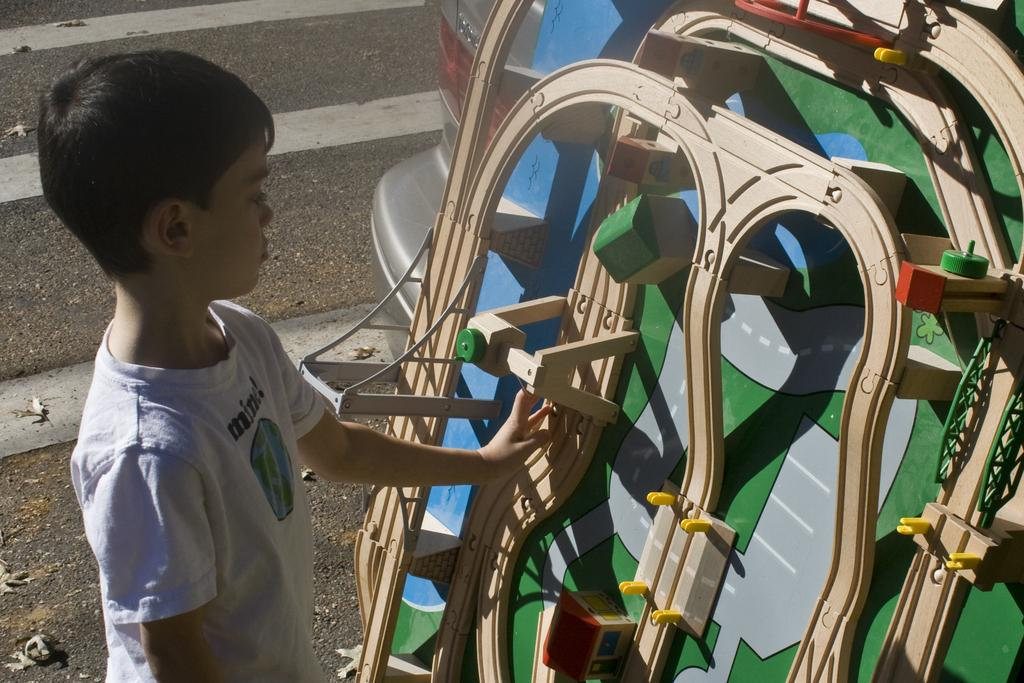What is the main subject of the image? The main subject of the image is a kid. What is the kid wearing? The kid is wearing a white dress. What is the kid's posture in the image? The kid is standing. What can be seen in front of the kid? There is an object in front of the kid. What type of cook is present in the image? There is no cook present in the image; it features a kid wearing a white dress and standing in front of an object. 